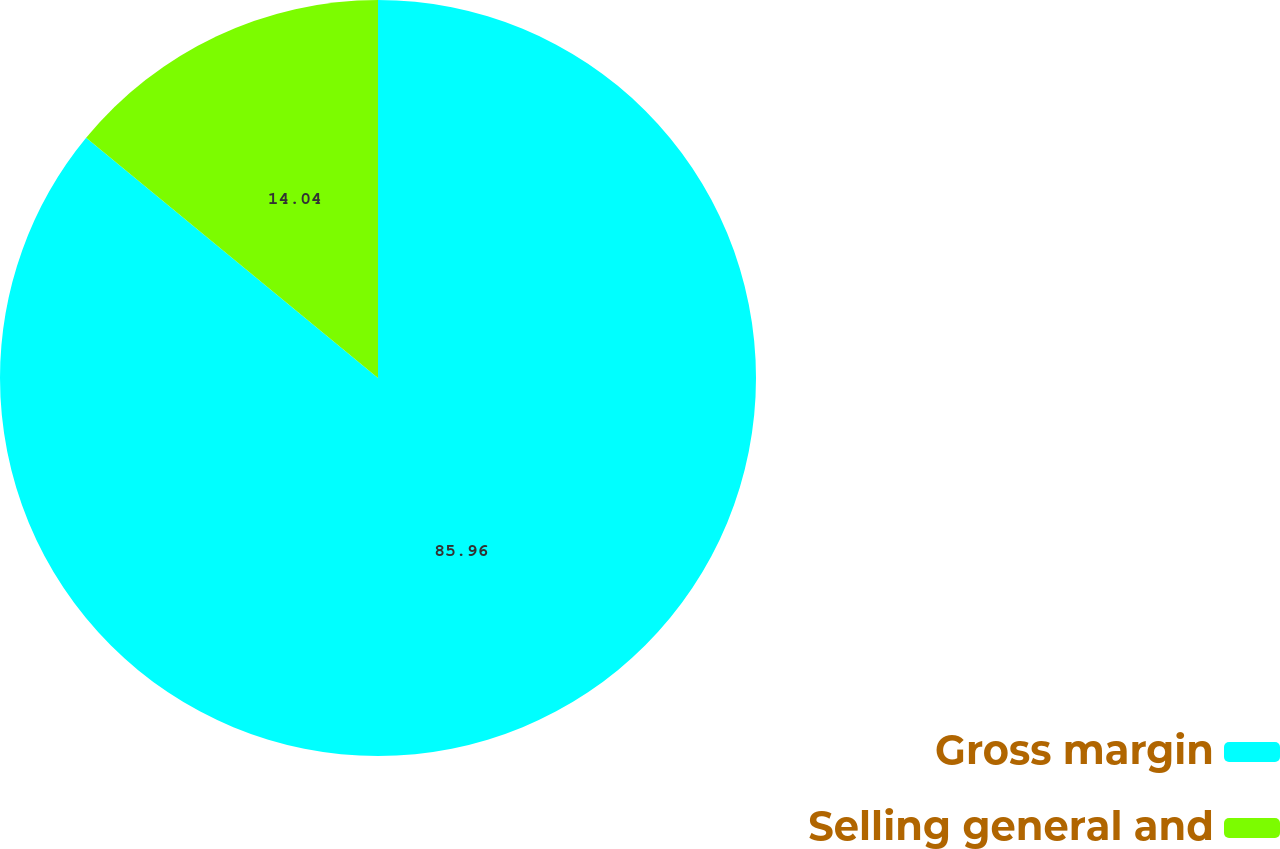<chart> <loc_0><loc_0><loc_500><loc_500><pie_chart><fcel>Gross margin<fcel>Selling general and<nl><fcel>85.96%<fcel>14.04%<nl></chart> 